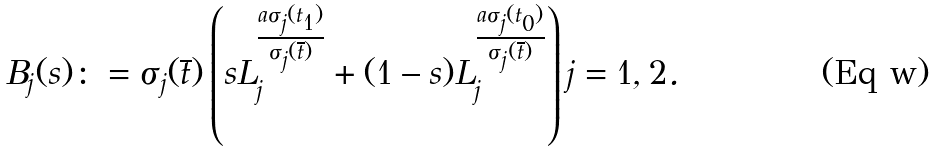<formula> <loc_0><loc_0><loc_500><loc_500>B _ { j } ( s ) \colon = \sigma _ { j } ( \overline { t } ) \left ( s L _ { j } ^ { \frac { a \sigma _ { j } ( t _ { 1 } ) } { \sigma _ { j } ( \overline { t } ) } } + ( 1 - s ) L _ { j } ^ { \frac { a \sigma _ { j } ( t _ { 0 } ) } { \sigma _ { j } ( \overline { t } ) } } \right ) j = 1 , 2 .</formula> 